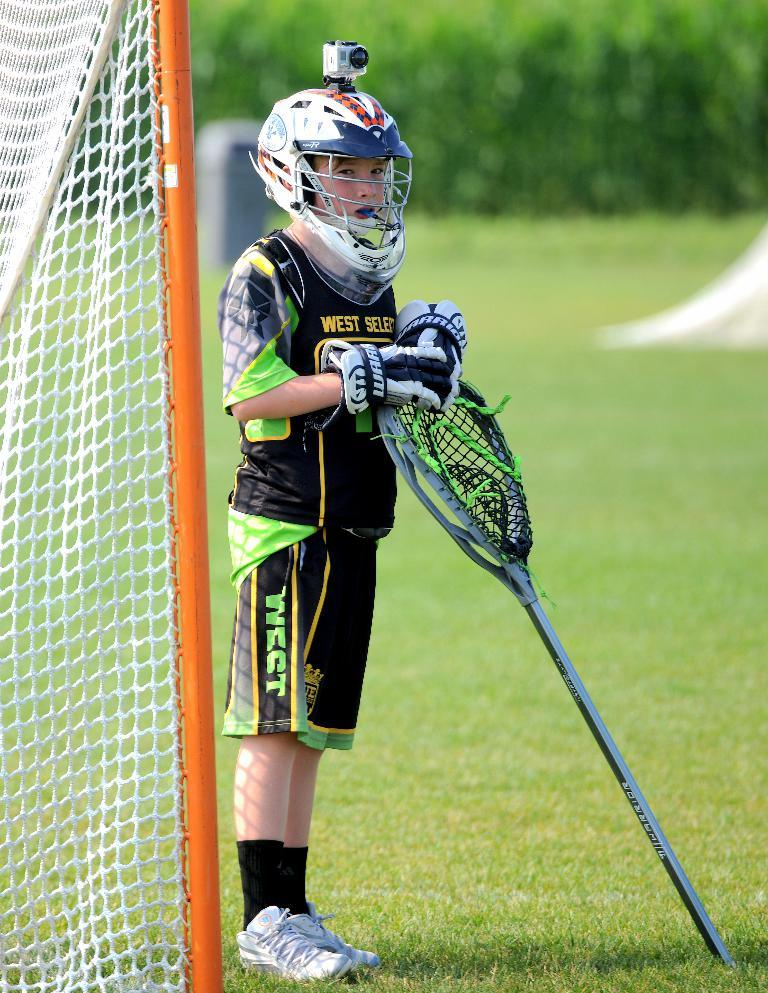Who is the main subject in the image? There is a boy in the image. What is the boy standing beside? The boy is standing beside a net. What is the boy wearing? The boy is wearing a complete game costume. What is the boy holding in his hands? The boy is holding an object in his hands. How is the background of the boy depicted? The background of the boy is blurred. What type of glove is the boy wearing on his face in the image? The boy is not wearing a glove on his face in the image. The boy is wearing a complete game costume, but it does not include a glove on his face. 